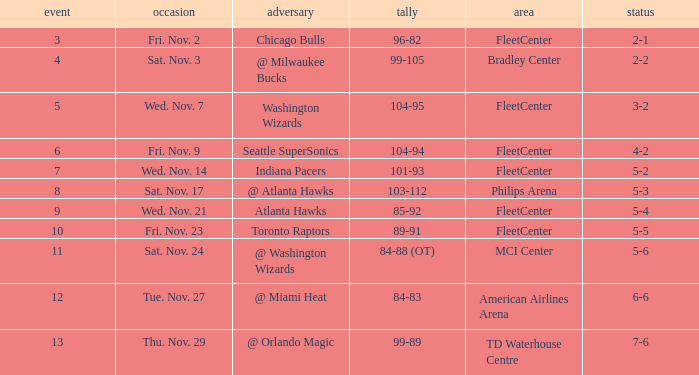What game has a score of 89-91? 10.0. 